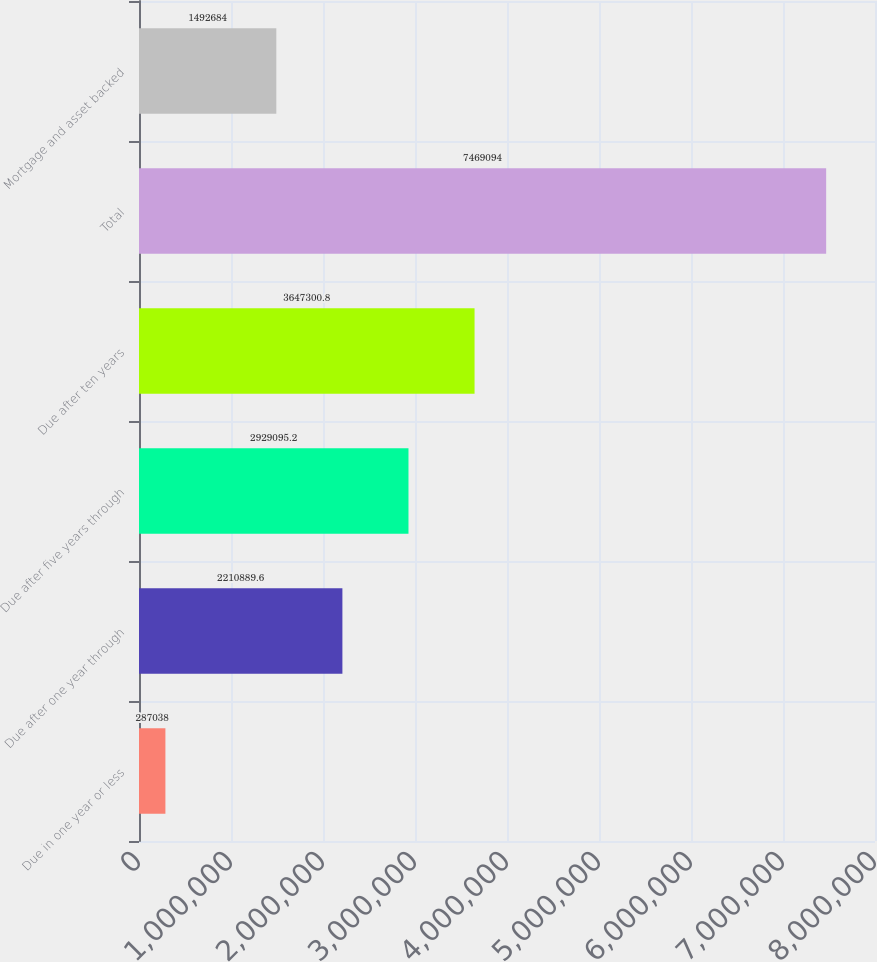<chart> <loc_0><loc_0><loc_500><loc_500><bar_chart><fcel>Due in one year or less<fcel>Due after one year through<fcel>Due after five years through<fcel>Due after ten years<fcel>Total<fcel>Mortgage and asset backed<nl><fcel>287038<fcel>2.21089e+06<fcel>2.9291e+06<fcel>3.6473e+06<fcel>7.46909e+06<fcel>1.49268e+06<nl></chart> 